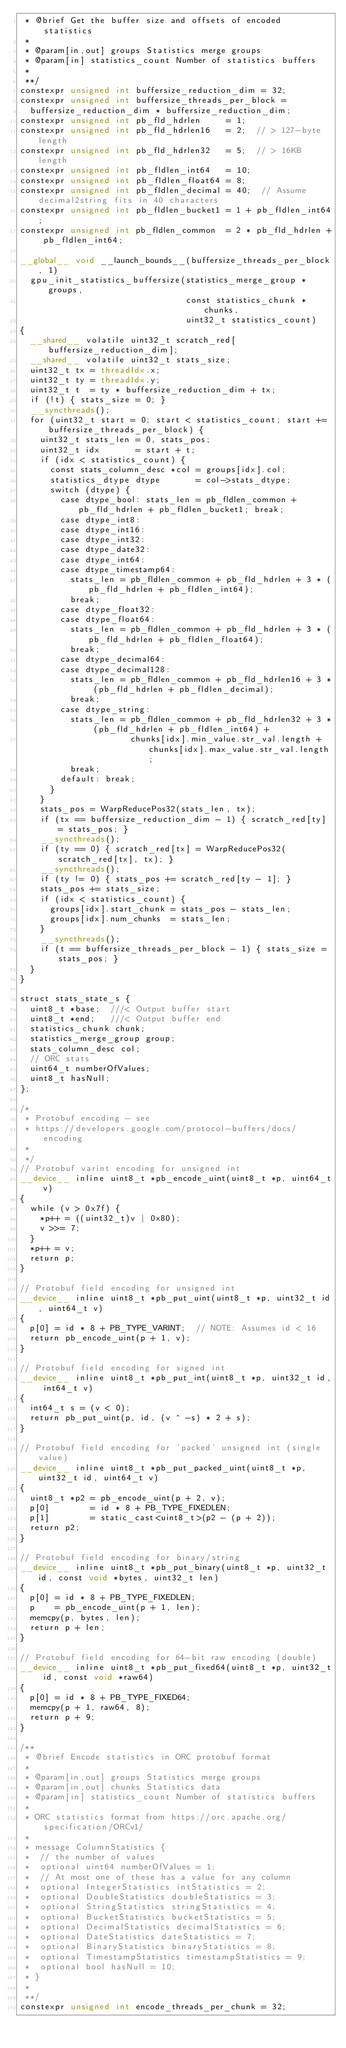Convert code to text. <code><loc_0><loc_0><loc_500><loc_500><_Cuda_> * @brief Get the buffer size and offsets of encoded statistics
 *
 * @param[in,out] groups Statistics merge groups
 * @param[in] statistics_count Number of statistics buffers
 *
 **/
constexpr unsigned int buffersize_reduction_dim = 32;
constexpr unsigned int buffersize_threads_per_block =
  buffersize_reduction_dim * buffersize_reduction_dim;
constexpr unsigned int pb_fld_hdrlen     = 1;
constexpr unsigned int pb_fld_hdrlen16   = 2;  // > 127-byte length
constexpr unsigned int pb_fld_hdrlen32   = 5;  // > 16KB length
constexpr unsigned int pb_fldlen_int64   = 10;
constexpr unsigned int pb_fldlen_float64 = 8;
constexpr unsigned int pb_fldlen_decimal = 40;  // Assume decimal2string fits in 40 characters
constexpr unsigned int pb_fldlen_bucket1 = 1 + pb_fldlen_int64;
constexpr unsigned int pb_fldlen_common  = 2 * pb_fld_hdrlen + pb_fldlen_int64;

__global__ void __launch_bounds__(buffersize_threads_per_block, 1)
  gpu_init_statistics_buffersize(statistics_merge_group *groups,
                                 const statistics_chunk *chunks,
                                 uint32_t statistics_count)
{
  __shared__ volatile uint32_t scratch_red[buffersize_reduction_dim];
  __shared__ volatile uint32_t stats_size;
  uint32_t tx = threadIdx.x;
  uint32_t ty = threadIdx.y;
  uint32_t t  = ty * buffersize_reduction_dim + tx;
  if (!t) { stats_size = 0; }
  __syncthreads();
  for (uint32_t start = 0; start < statistics_count; start += buffersize_threads_per_block) {
    uint32_t stats_len = 0, stats_pos;
    uint32_t idx       = start + t;
    if (idx < statistics_count) {
      const stats_column_desc *col = groups[idx].col;
      statistics_dtype dtype       = col->stats_dtype;
      switch (dtype) {
        case dtype_bool: stats_len = pb_fldlen_common + pb_fld_hdrlen + pb_fldlen_bucket1; break;
        case dtype_int8:
        case dtype_int16:
        case dtype_int32:
        case dtype_date32:
        case dtype_int64:
        case dtype_timestamp64:
          stats_len = pb_fldlen_common + pb_fld_hdrlen + 3 * (pb_fld_hdrlen + pb_fldlen_int64);
          break;
        case dtype_float32:
        case dtype_float64:
          stats_len = pb_fldlen_common + pb_fld_hdrlen + 3 * (pb_fld_hdrlen + pb_fldlen_float64);
          break;
        case dtype_decimal64:
        case dtype_decimal128:
          stats_len = pb_fldlen_common + pb_fld_hdrlen16 + 3 * (pb_fld_hdrlen + pb_fldlen_decimal);
          break;
        case dtype_string:
          stats_len = pb_fldlen_common + pb_fld_hdrlen32 + 3 * (pb_fld_hdrlen + pb_fldlen_int64) +
                      chunks[idx].min_value.str_val.length + chunks[idx].max_value.str_val.length;
          break;
        default: break;
      }
    }
    stats_pos = WarpReducePos32(stats_len, tx);
    if (tx == buffersize_reduction_dim - 1) { scratch_red[ty] = stats_pos; }
    __syncthreads();
    if (ty == 0) { scratch_red[tx] = WarpReducePos32(scratch_red[tx], tx); }
    __syncthreads();
    if (ty != 0) { stats_pos += scratch_red[ty - 1]; }
    stats_pos += stats_size;
    if (idx < statistics_count) {
      groups[idx].start_chunk = stats_pos - stats_len;
      groups[idx].num_chunks  = stats_len;
    }
    __syncthreads();
    if (t == buffersize_threads_per_block - 1) { stats_size = stats_pos; }
  }
}

struct stats_state_s {
  uint8_t *base;  ///< Output buffer start
  uint8_t *end;   ///< Output buffer end
  statistics_chunk chunk;
  statistics_merge_group group;
  stats_column_desc col;
  // ORC stats
  uint64_t numberOfValues;
  uint8_t hasNull;
};

/*
 * Protobuf encoding - see
 * https://developers.google.com/protocol-buffers/docs/encoding
 *
 */
// Protobuf varint encoding for unsigned int
__device__ inline uint8_t *pb_encode_uint(uint8_t *p, uint64_t v)
{
  while (v > 0x7f) {
    *p++ = ((uint32_t)v | 0x80);
    v >>= 7;
  }
  *p++ = v;
  return p;
}

// Protobuf field encoding for unsigned int
__device__ inline uint8_t *pb_put_uint(uint8_t *p, uint32_t id, uint64_t v)
{
  p[0] = id * 8 + PB_TYPE_VARINT;  // NOTE: Assumes id < 16
  return pb_encode_uint(p + 1, v);
}

// Protobuf field encoding for signed int
__device__ inline uint8_t *pb_put_int(uint8_t *p, uint32_t id, int64_t v)
{
  int64_t s = (v < 0);
  return pb_put_uint(p, id, (v ^ -s) * 2 + s);
}

// Protobuf field encoding for 'packed' unsigned int (single value)
__device__ inline uint8_t *pb_put_packed_uint(uint8_t *p, uint32_t id, uint64_t v)
{
  uint8_t *p2 = pb_encode_uint(p + 2, v);
  p[0]        = id * 8 + PB_TYPE_FIXEDLEN;
  p[1]        = static_cast<uint8_t>(p2 - (p + 2));
  return p2;
}

// Protobuf field encoding for binary/string
__device__ inline uint8_t *pb_put_binary(uint8_t *p, uint32_t id, const void *bytes, uint32_t len)
{
  p[0] = id * 8 + PB_TYPE_FIXEDLEN;
  p    = pb_encode_uint(p + 1, len);
  memcpy(p, bytes, len);
  return p + len;
}

// Protobuf field encoding for 64-bit raw encoding (double)
__device__ inline uint8_t *pb_put_fixed64(uint8_t *p, uint32_t id, const void *raw64)
{
  p[0] = id * 8 + PB_TYPE_FIXED64;
  memcpy(p + 1, raw64, 8);
  return p + 9;
}

/**
 * @brief Encode statistics in ORC protobuf format
 *
 * @param[in,out] groups Statistics merge groups
 * @param[in,out] chunks Statistics data
 * @param[in] statistics_count Number of statistics buffers
 *
 * ORC statistics format from https://orc.apache.org/specification/ORCv1/
 *
 * message ColumnStatistics {
 *  // the number of values
 *  optional uint64 numberOfValues = 1;
 *  // At most one of these has a value for any column
 *  optional IntegerStatistics intStatistics = 2;
 *  optional DoubleStatistics doubleStatistics = 3;
 *  optional StringStatistics stringStatistics = 4;
 *  optional BucketStatistics bucketStatistics = 5;
 *  optional DecimalStatistics decimalStatistics = 6;
 *  optional DateStatistics dateStatistics = 7;
 *  optional BinaryStatistics binaryStatistics = 8;
 *  optional TimestampStatistics timestampStatistics = 9;
 *  optional bool hasNull = 10;
 * }
 *
 **/
constexpr unsigned int encode_threads_per_chunk = 32;</code> 